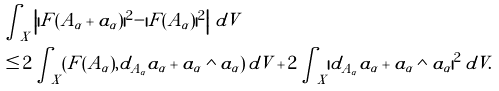<formula> <loc_0><loc_0><loc_500><loc_500>& \int _ { X } \left | | F ( A _ { \alpha } + a _ { \alpha } ) | ^ { 2 } - | F ( A _ { \alpha } ) | ^ { 2 } \right | \, d V \\ & \leq 2 \int _ { X } ( F ( A _ { \alpha } ) , d _ { A _ { \alpha } } a _ { \alpha } + a _ { \alpha } \wedge a _ { \alpha } ) \, d V + 2 \int _ { X } | d _ { A _ { \alpha } } a _ { \alpha } + a _ { \alpha } \wedge a _ { \alpha } | ^ { 2 } \, d V .</formula> 